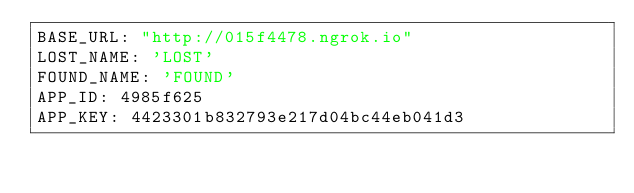<code> <loc_0><loc_0><loc_500><loc_500><_YAML_>BASE_URL: "http://015f4478.ngrok.io"
LOST_NAME: 'LOST'
FOUND_NAME: 'FOUND'
APP_ID: 4985f625
APP_KEY: 4423301b832793e217d04bc44eb041d3
</code> 